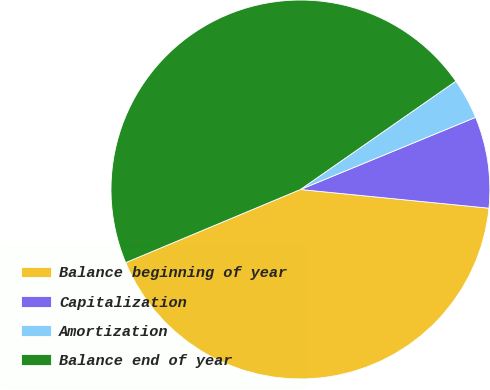Convert chart to OTSL. <chart><loc_0><loc_0><loc_500><loc_500><pie_chart><fcel>Balance beginning of year<fcel>Capitalization<fcel>Amortization<fcel>Balance end of year<nl><fcel>42.12%<fcel>7.79%<fcel>3.47%<fcel>46.62%<nl></chart> 